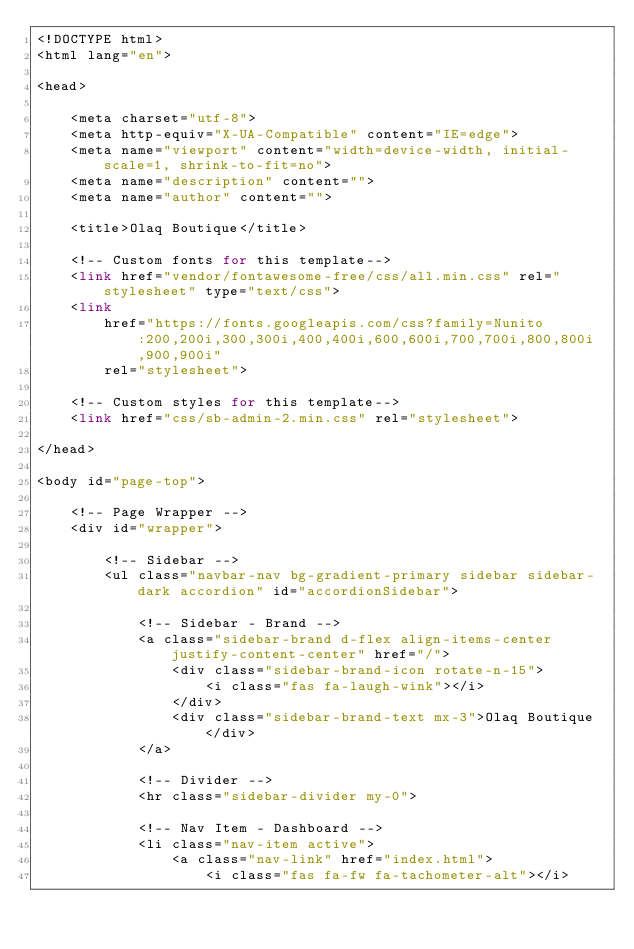Convert code to text. <code><loc_0><loc_0><loc_500><loc_500><_PHP_><!DOCTYPE html>
<html lang="en">

<head>

    <meta charset="utf-8">
    <meta http-equiv="X-UA-Compatible" content="IE=edge">
    <meta name="viewport" content="width=device-width, initial-scale=1, shrink-to-fit=no">
    <meta name="description" content="">
    <meta name="author" content="">

    <title>Olaq Boutique</title>

    <!-- Custom fonts for this template-->
    <link href="vendor/fontawesome-free/css/all.min.css" rel="stylesheet" type="text/css">
    <link
        href="https://fonts.googleapis.com/css?family=Nunito:200,200i,300,300i,400,400i,600,600i,700,700i,800,800i,900,900i"
        rel="stylesheet">

    <!-- Custom styles for this template-->
    <link href="css/sb-admin-2.min.css" rel="stylesheet">

</head>

<body id="page-top">

    <!-- Page Wrapper -->
    <div id="wrapper">

        <!-- Sidebar -->
        <ul class="navbar-nav bg-gradient-primary sidebar sidebar-dark accordion" id="accordionSidebar">

            <!-- Sidebar - Brand -->
            <a class="sidebar-brand d-flex align-items-center justify-content-center" href="/">
                <div class="sidebar-brand-icon rotate-n-15">
                    <i class="fas fa-laugh-wink"></i>
                </div>
                <div class="sidebar-brand-text mx-3">Olaq Boutique</div>
            </a>

            <!-- Divider -->
            <hr class="sidebar-divider my-0">

            <!-- Nav Item - Dashboard -->
            <li class="nav-item active">
                <a class="nav-link" href="index.html">
                    <i class="fas fa-fw fa-tachometer-alt"></i></code> 